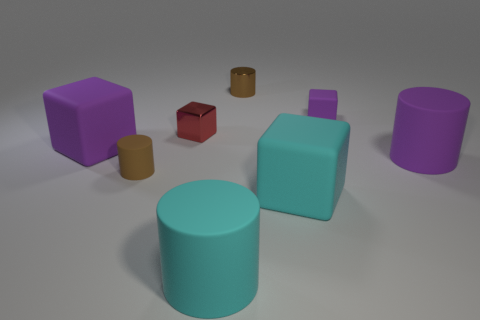Subtract all cyan cylinders. How many cylinders are left? 3 Add 1 brown rubber cylinders. How many objects exist? 9 Subtract all cyan cylinders. How many cylinders are left? 3 Subtract all yellow balls. How many cyan cylinders are left? 1 Subtract all gray metallic cylinders. Subtract all metal cylinders. How many objects are left? 7 Add 3 large cubes. How many large cubes are left? 5 Add 8 tiny purple matte blocks. How many tiny purple matte blocks exist? 9 Subtract 2 brown cylinders. How many objects are left? 6 Subtract 3 cylinders. How many cylinders are left? 1 Subtract all cyan blocks. Subtract all blue cylinders. How many blocks are left? 3 